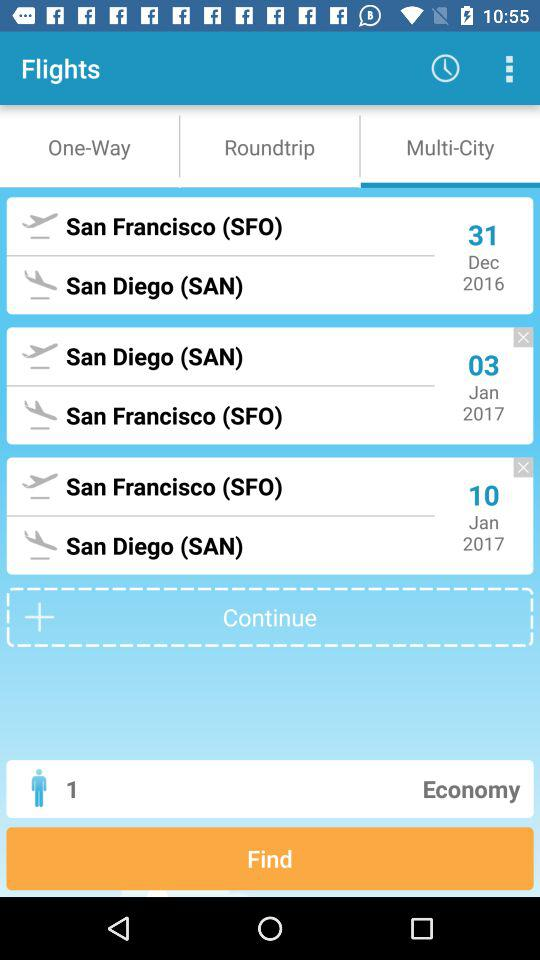What's the flight ticket class? The flight ticket class is economy. 